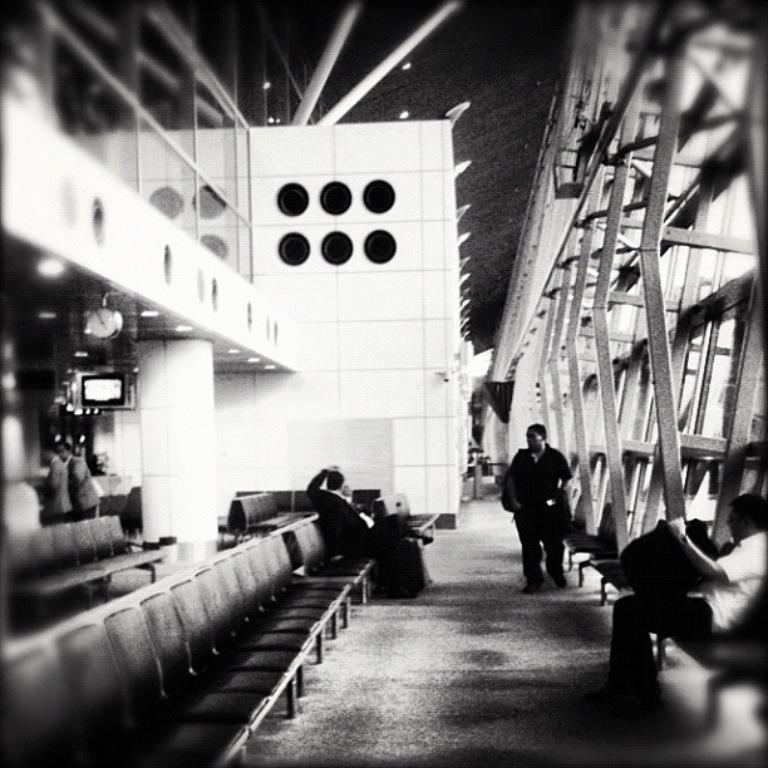What is the color scheme of the image? The image is black and white. What can be seen in the hall in the image? There are persons sitting on chairs on either side in the hall. What is happening outside the hall in the image? There is a person walking on a path. What type of pear is being held by the person walking on the path in the image? There is no pear present in the image; the person walking on the path is not holding any fruit. Can you describe the taste of the person's tongue in the image? There is no information about the person's tongue in the image, so it is impossible to describe its taste. 